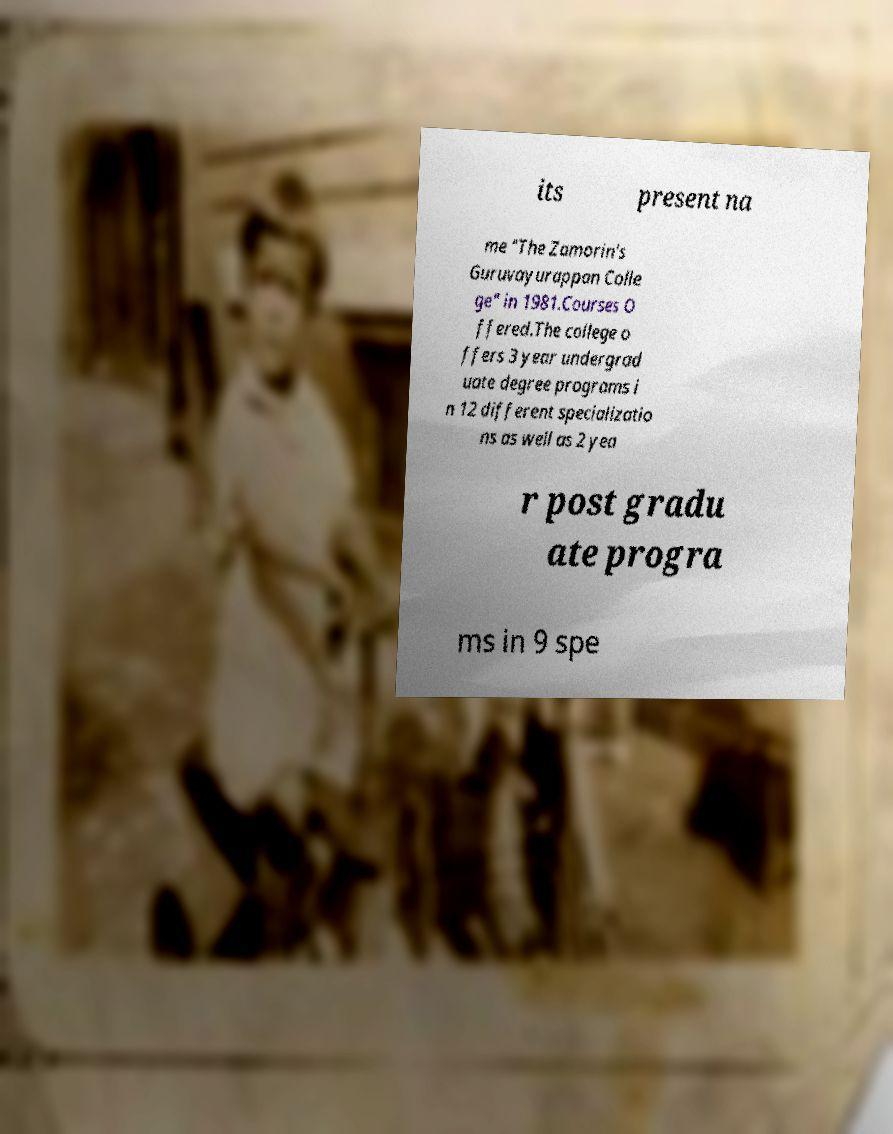What messages or text are displayed in this image? I need them in a readable, typed format. its present na me "The Zamorin's Guruvayurappan Colle ge" in 1981.Courses O ffered.The college o ffers 3 year undergrad uate degree programs i n 12 different specializatio ns as well as 2 yea r post gradu ate progra ms in 9 spe 